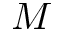<formula> <loc_0><loc_0><loc_500><loc_500>M</formula> 